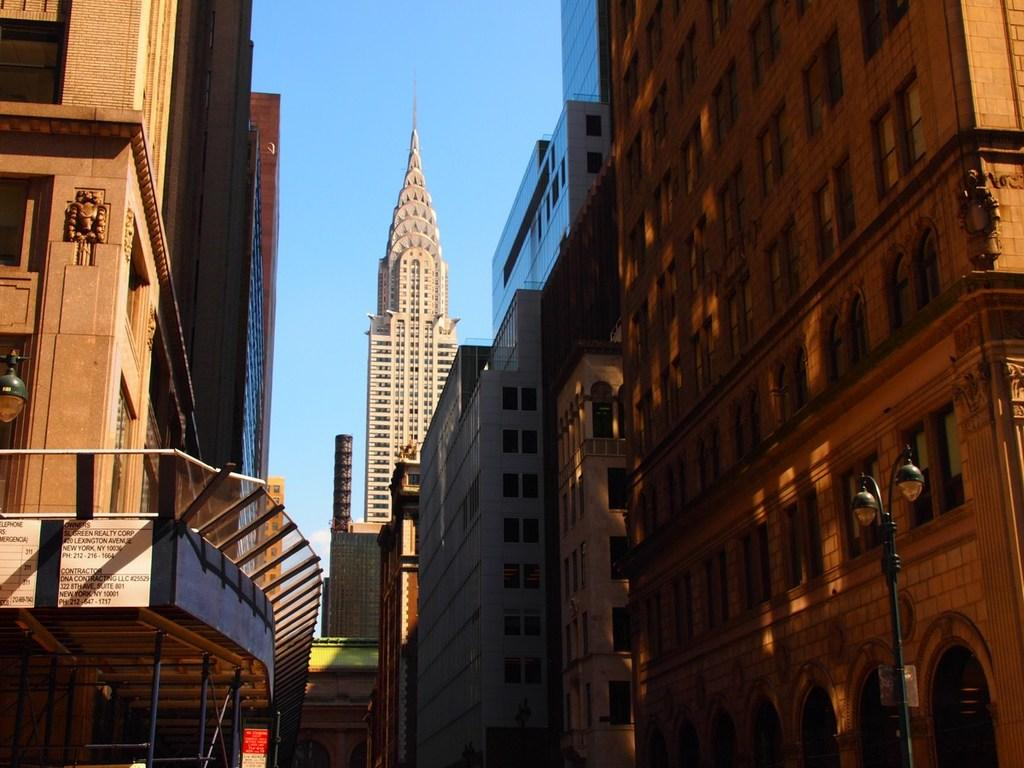What type of structures can be seen in the image? There are buildings and towers in the image. What is the height of the light pole in the image? The height of the light pole cannot be determined from the image. What color is the sky in the image? The sky is blue in the image. When might this image have been taken? The image was likely taken during the day, given the blue sky. What direction is the earth facing in the image? The image does not show the earth, so it is not possible to determine the direction it is facing. 